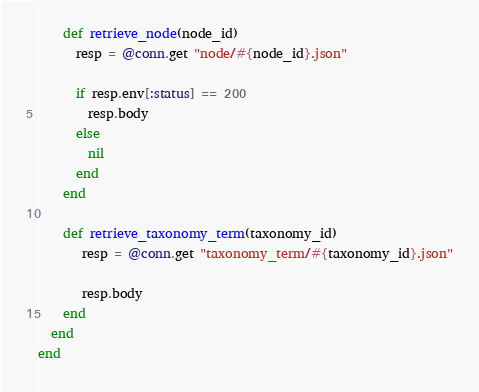Convert code to text. <code><loc_0><loc_0><loc_500><loc_500><_Ruby_>
    def retrieve_node(node_id)
      resp = @conn.get "node/#{node_id}.json"

      if resp.env[:status] == 200
        resp.body
      else
        nil
      end
    end

    def retrieve_taxonomy_term(taxonomy_id)
       resp = @conn.get "taxonomy_term/#{taxonomy_id}.json"

       resp.body
    end
  end
end
</code> 